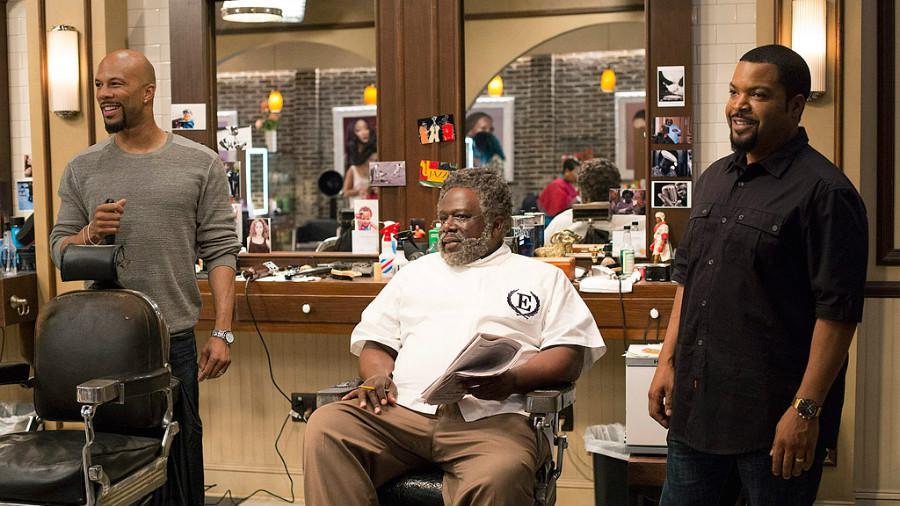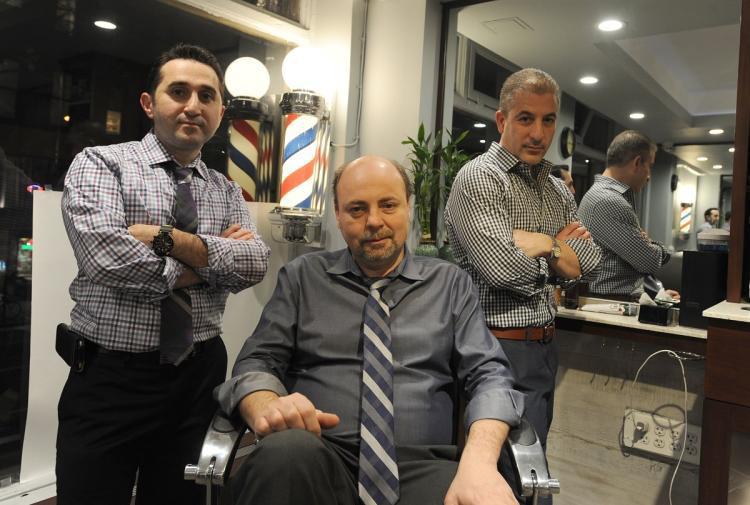The first image is the image on the left, the second image is the image on the right. Assess this claim about the two images: "One man is sitting between two other men in the image on the right.". Correct or not? Answer yes or no. Yes. The first image is the image on the left, the second image is the image on the right. Assess this claim about the two images: "A female wearing black stands in the foreground of the image on the left.". Correct or not? Answer yes or no. No. 